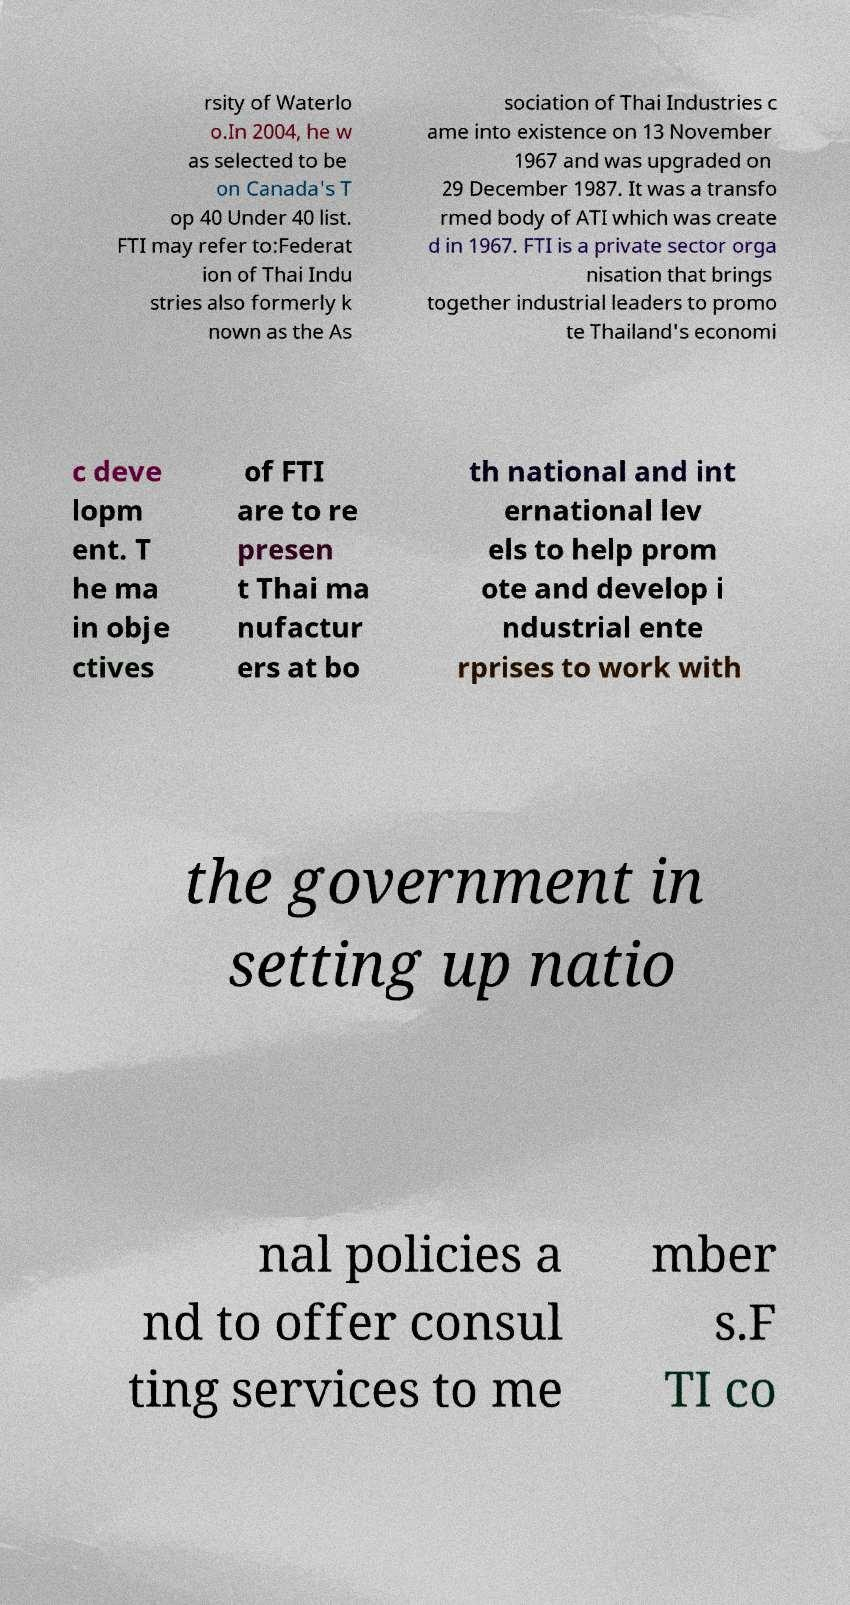Please identify and transcribe the text found in this image. rsity of Waterlo o.In 2004, he w as selected to be on Canada's T op 40 Under 40 list. FTI may refer to:Federat ion of Thai Indu stries also formerly k nown as the As sociation of Thai Industries c ame into existence on 13 November 1967 and was upgraded on 29 December 1987. It was a transfo rmed body of ATI which was create d in 1967. FTI is a private sector orga nisation that brings together industrial leaders to promo te Thailand's economi c deve lopm ent. T he ma in obje ctives of FTI are to re presen t Thai ma nufactur ers at bo th national and int ernational lev els to help prom ote and develop i ndustrial ente rprises to work with the government in setting up natio nal policies a nd to offer consul ting services to me mber s.F TI co 